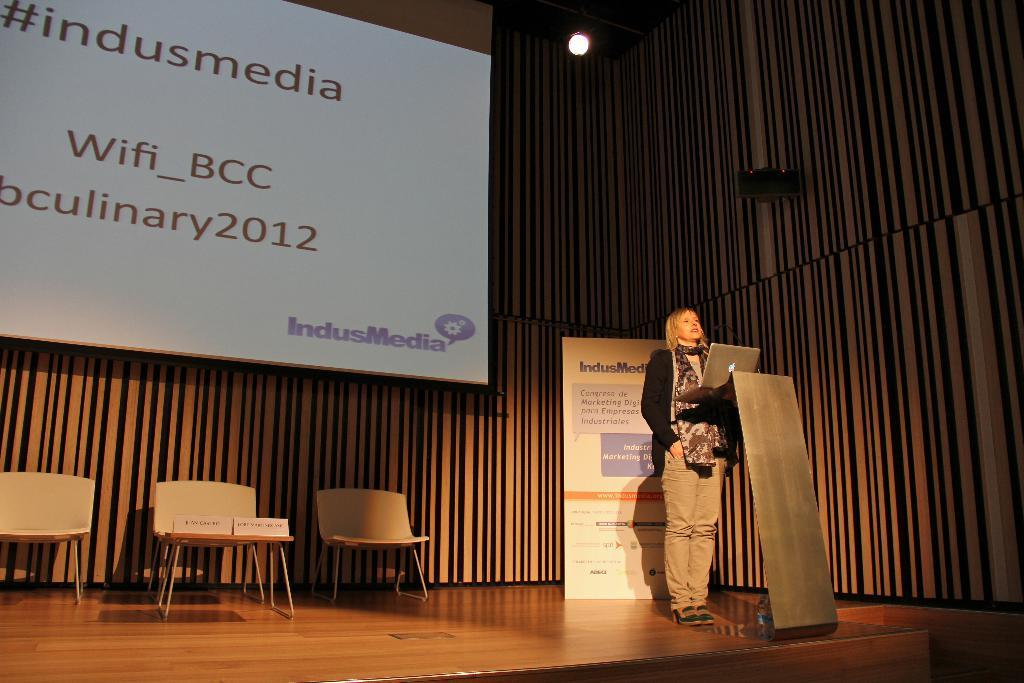What is the main subject of the image? The main subject of the image is a woman standing. Can you describe the background of the image? There is a board with text in the background of the image. What type of silver object is being discussed at the meeting in the image? There is no meeting or silver object present in the image. Who is the expert on the topic being discussed at the meeting in the image? There is no meeting or expert present in the image. 